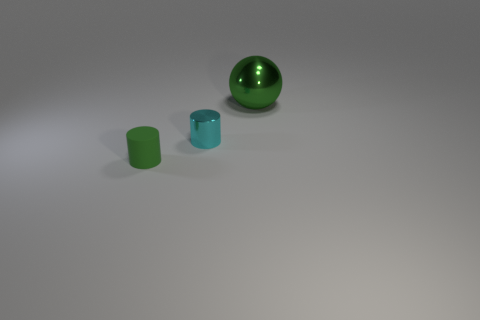Add 1 cylinders. How many objects exist? 4 Subtract all cylinders. How many objects are left? 1 Subtract 0 gray cylinders. How many objects are left? 3 Subtract all big gray shiny things. Subtract all large metal objects. How many objects are left? 2 Add 3 tiny green cylinders. How many tiny green cylinders are left? 4 Add 3 tiny red cubes. How many tiny red cubes exist? 3 